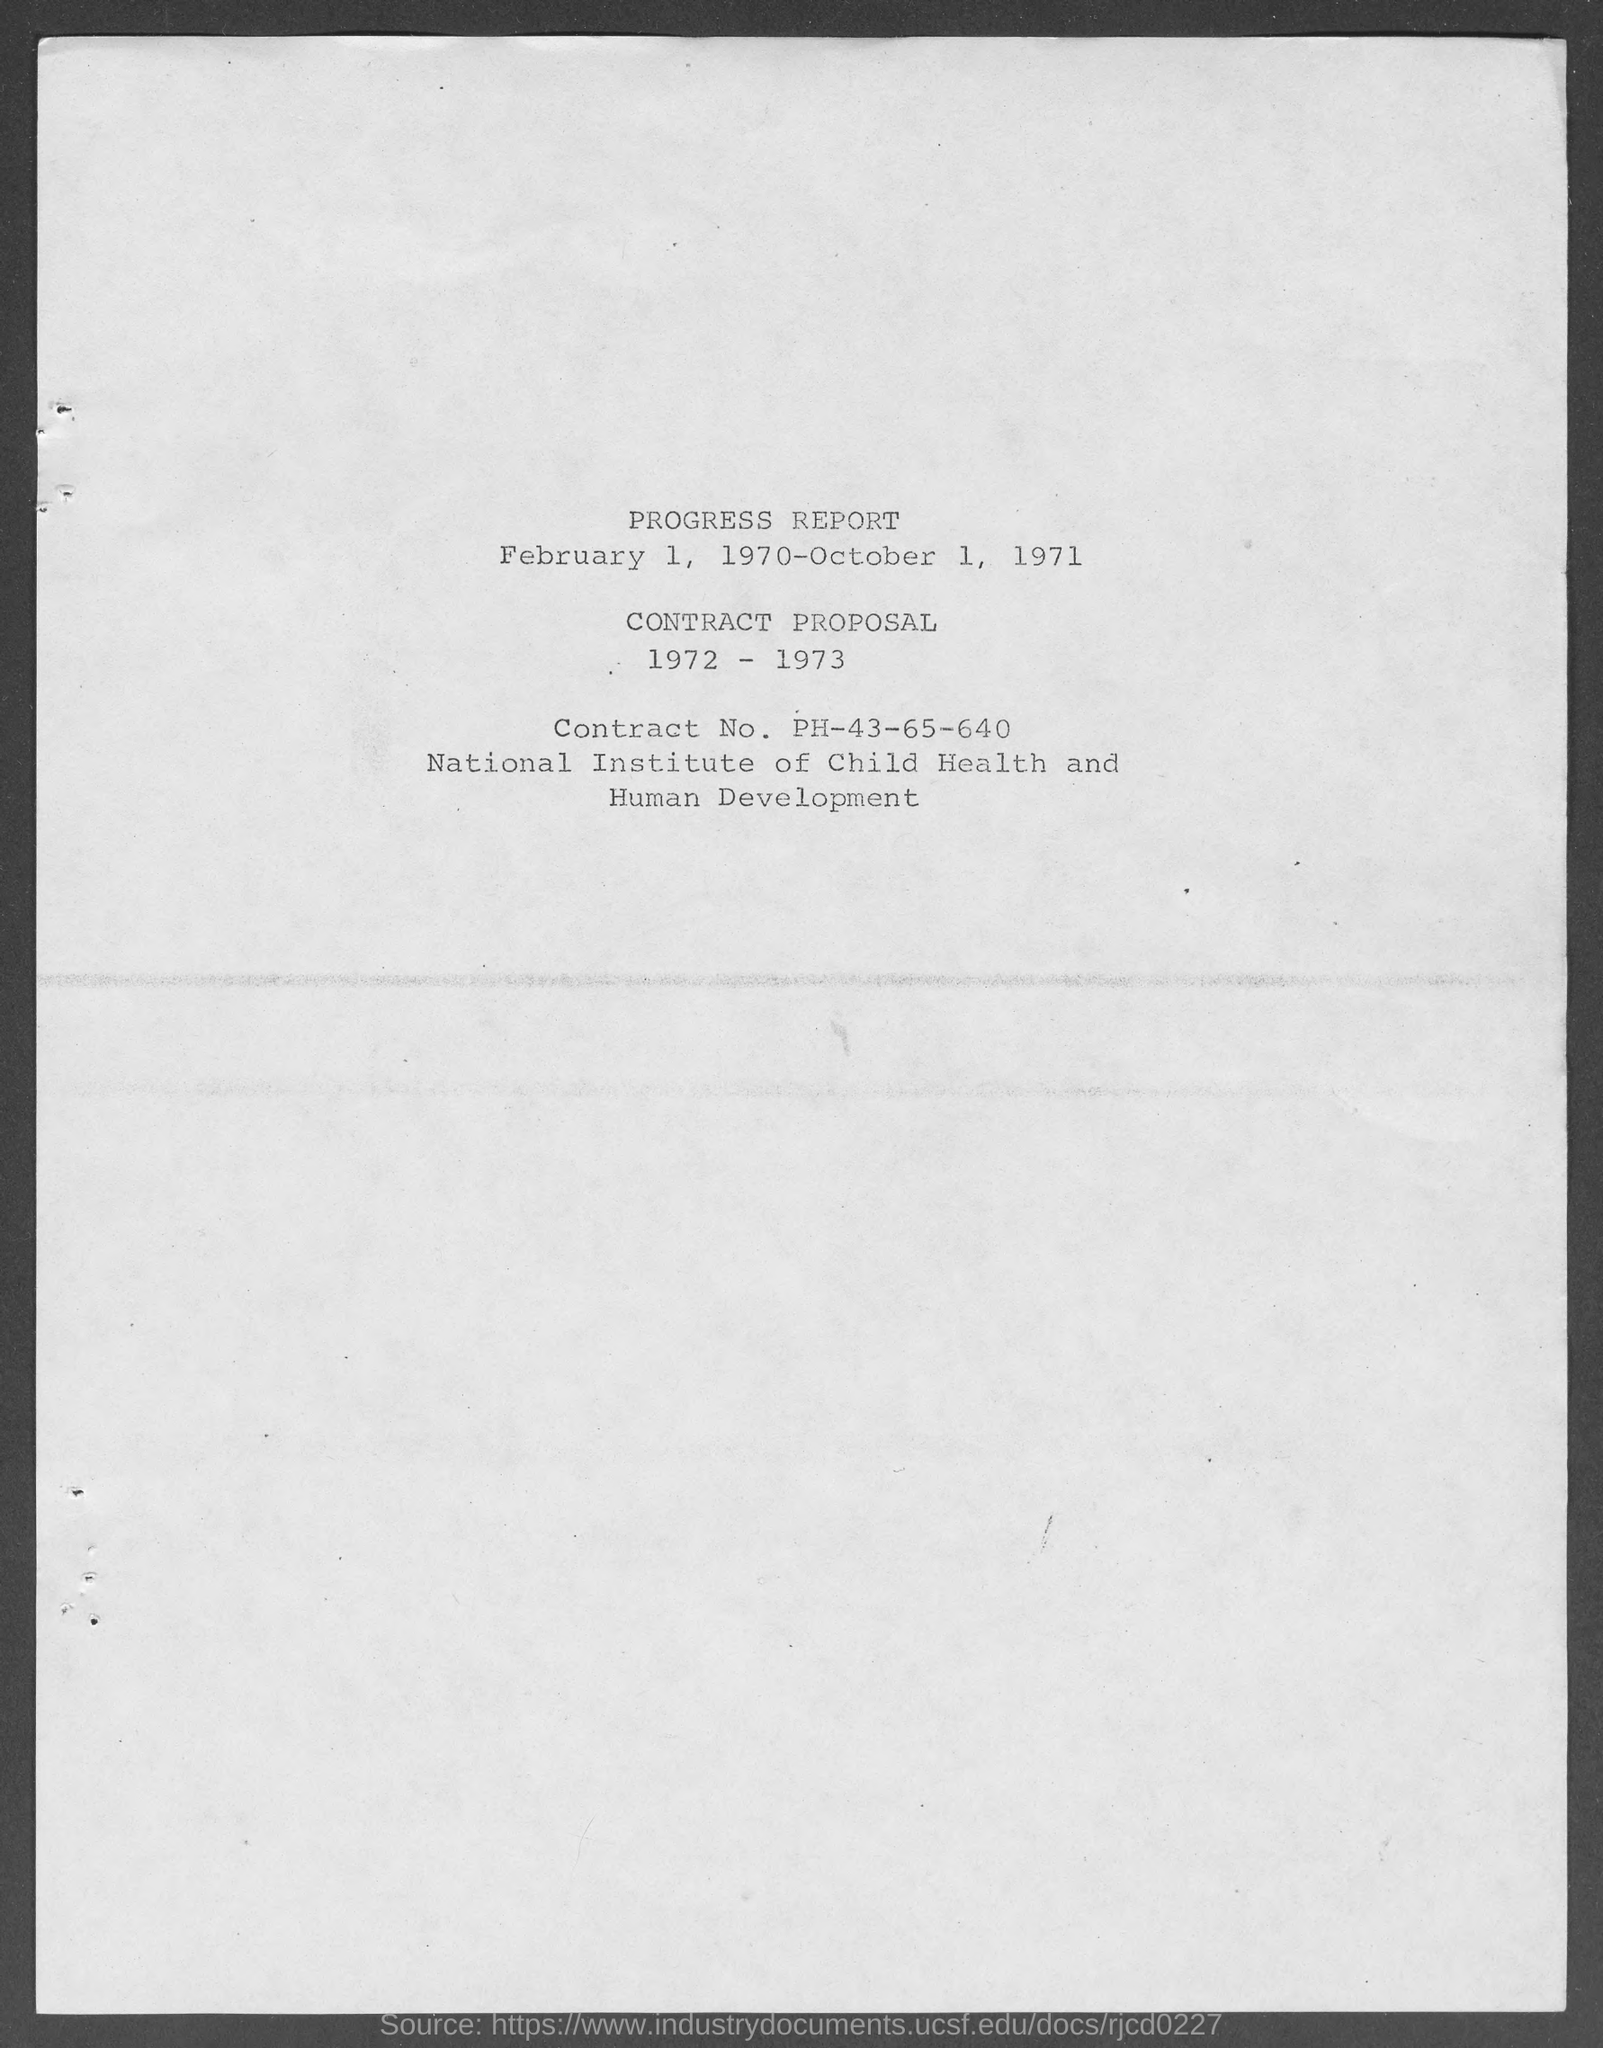What is the Contract No. of the Institution?
Give a very brief answer. Contract No. PH-43-65-640. 